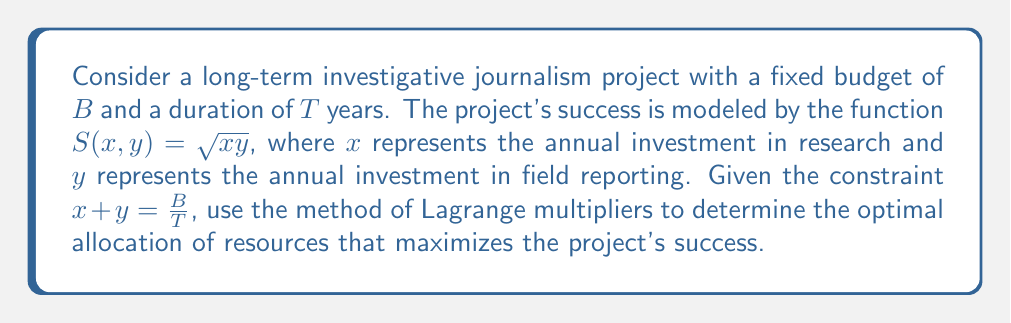Can you solve this math problem? 1) We need to maximize $S(x,y) = \sqrt{xy}$ subject to the constraint $g(x,y) = x + y - \frac{B}{T} = 0$.

2) Form the Lagrangian function:
   $$L(x, y, \lambda) = \sqrt{xy} - \lambda(x + y - \frac{B}{T})$$

3) Calculate partial derivatives and set them to zero:
   $$\frac{\partial L}{\partial x} = \frac{y}{2\sqrt{xy}} - \lambda = 0$$
   $$\frac{\partial L}{\partial y} = \frac{x}{2\sqrt{xy}} - \lambda = 0$$
   $$\frac{\partial L}{\partial \lambda} = x + y - \frac{B}{T} = 0$$

4) From the first two equations:
   $$\frac{y}{2\sqrt{xy}} = \frac{x}{2\sqrt{xy}}$$
   This implies $x = y$.

5) Substitute this into the constraint equation:
   $$x + x = \frac{B}{T}$$
   $$2x = \frac{B}{T}$$

6) Solve for x and y:
   $$x = y = \frac{B}{2T}$$

7) This means the optimal allocation is to split the annual budget equally between research and field reporting.
Answer: $x = y = \frac{B}{2T}$ 